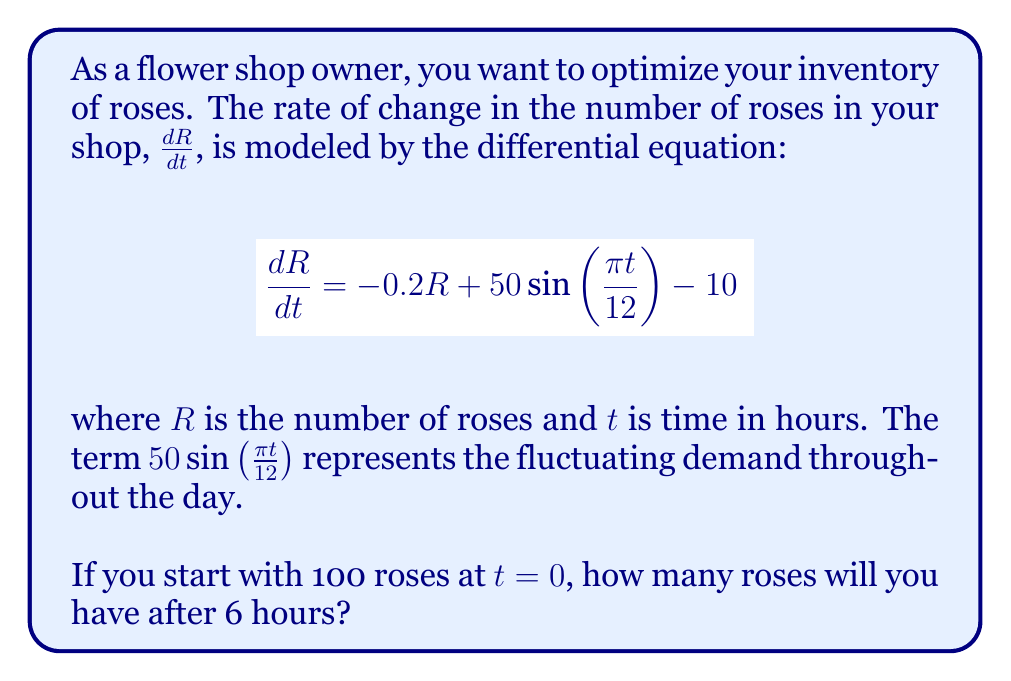Solve this math problem. To solve this problem, we need to use the method for solving first-order linear differential equations. Let's go through it step-by-step:

1) The general form of a first-order linear DE is:
   $$\frac{dR}{dt} + P(t)R = Q(t)$$

2) In our case:
   $P(t) = 0.2$ and $Q(t) = 50\sin(\frac{\pi t}{12}) - 10$

3) The integrating factor is $e^{\int P(t)dt} = e^{0.2t}$

4) Multiplying both sides of the equation by the integrating factor:
   $$e^{0.2t}\frac{dR}{dt} + 0.2e^{0.2t}R = e^{0.2t}(50\sin(\frac{\pi t}{12}) - 10)$$

5) This can be written as:
   $$\frac{d}{dt}(e^{0.2t}R) = e^{0.2t}(50\sin(\frac{\pi t}{12}) - 10)$$

6) Integrating both sides:
   $$e^{0.2t}R = \int e^{0.2t}(50\sin(\frac{\pi t}{12}) - 10)dt$$

7) Solving the integral:
   $$e^{0.2t}R = 50\int e^{0.2t}\sin(\frac{\pi t}{12})dt - 10\int e^{0.2t}dt + C$$
   
   $$e^{0.2t}R = 50(\frac{12}{\pi^2+2.4^2})(2.4e^{0.2t}\sin(\frac{\pi t}{12}) - \pi e^{0.2t}\cos(\frac{\pi t}{12})) - 50e^{0.2t} + C$$

8) Solving for R:
   $$R = 50(\frac{12}{\pi^2+2.4^2})(2.4\sin(\frac{\pi t}{12}) - \pi \cos(\frac{\pi t}{12})) - 50 + Ce^{-0.2t}$$

9) Using the initial condition $R(0) = 100$, we can find C:
   $$100 = -50(\frac{12\pi}{\pi^2+2.4^2}) - 50 + C$$
   $$C = 100 + 50(\frac{12\pi}{\pi^2+2.4^2}) + 50 = 150 + 50(\frac{12\pi}{\pi^2+2.4^2})$$

10) Substituting this back into our solution and evaluating at $t=6$:
    $$R(6) = 50(\frac{12}{\pi^2+2.4^2})(2.4\sin(\frac{\pi}{2}) - \pi \cos(\frac{\pi}{2})) - 50 + (150 + 50(\frac{12\pi}{\pi^2+2.4^2}))e^{-1.2}$$

11) Calculating this value gives us approximately 72.8 roses.
Answer: 73 roses (rounded to the nearest whole number) 